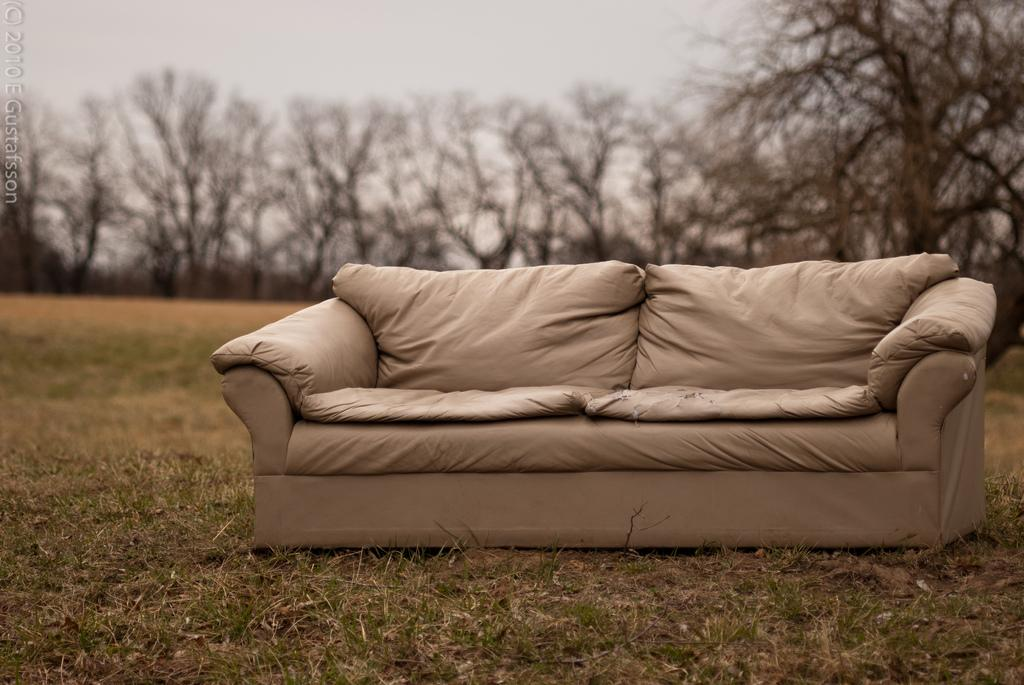What type of furniture is in the image? There is a sofa in the image. What type of vegetation is visible at the bottom of the image? Grass is present at the bottom of the image. What type of vegetation is visible at the top of the image? There are trees at the top of the image. What type of waves can be seen in the image? There are no waves present in the image. 